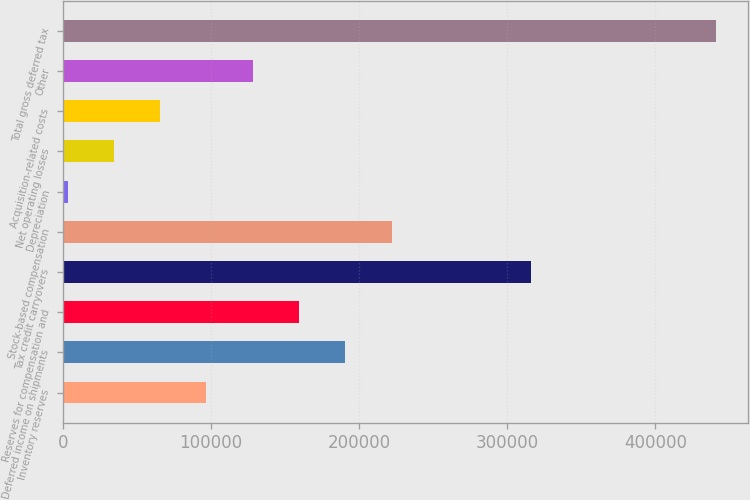Convert chart. <chart><loc_0><loc_0><loc_500><loc_500><bar_chart><fcel>Inventory reserves<fcel>Deferred income on shipments<fcel>Reserves for compensation and<fcel>Tax credit carryovers<fcel>Stock-based compensation<fcel>Depreciation<fcel>Net operating losses<fcel>Acquisition-related costs<fcel>Other<fcel>Total gross deferred tax<nl><fcel>96890.1<fcel>190702<fcel>159432<fcel>315785<fcel>221973<fcel>3078<fcel>34348.7<fcel>65619.4<fcel>128161<fcel>440868<nl></chart> 